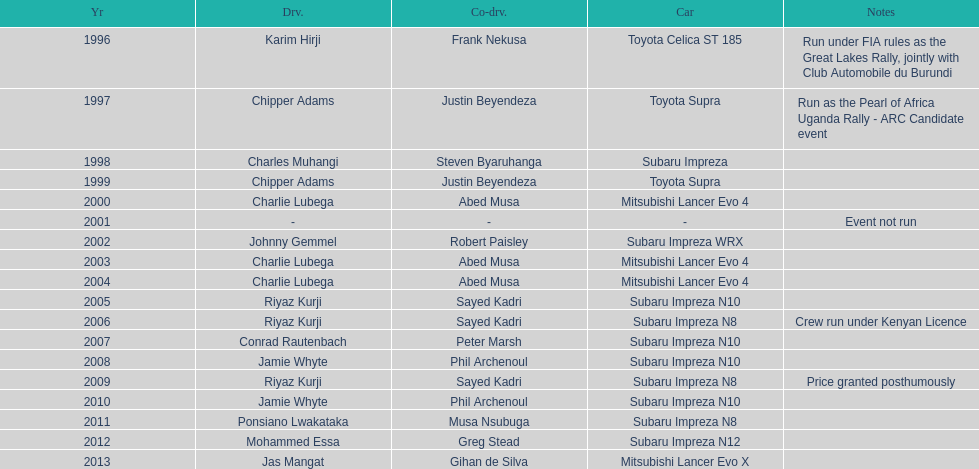How many drivers are racing with a co-driver from a different country? 1. 